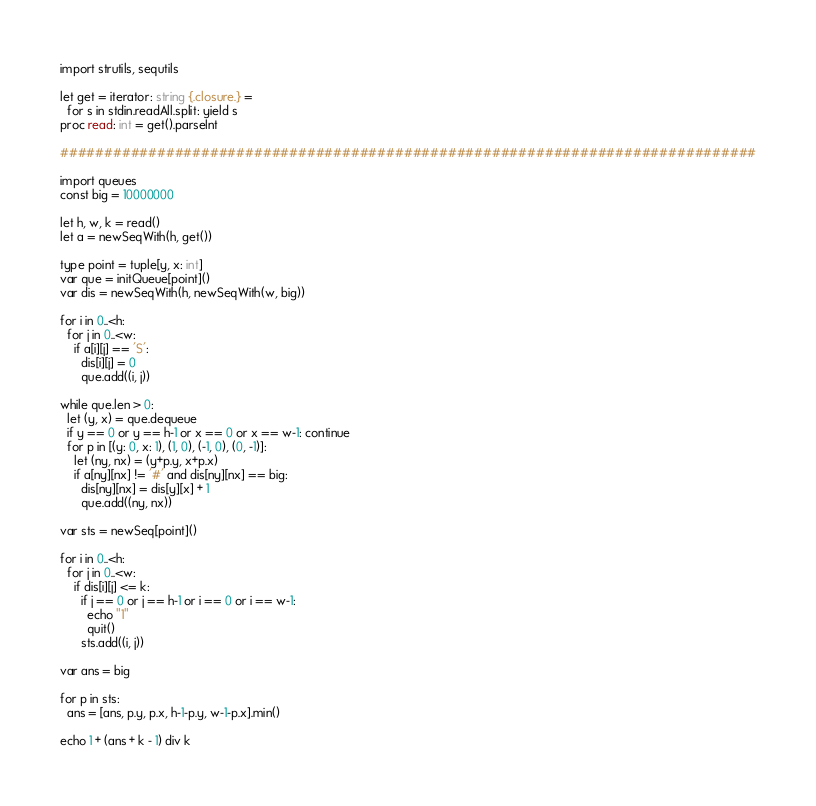<code> <loc_0><loc_0><loc_500><loc_500><_Nim_>import strutils, sequtils

let get = iterator: string {.closure.} =
  for s in stdin.readAll.split: yield s
proc read: int = get().parseInt

###############################################################################

import queues
const big = 10000000

let h, w, k = read()
let a = newSeqWith(h, get())

type point = tuple[y, x: int]
var que = initQueue[point]()
var dis = newSeqWith(h, newSeqWith(w, big))

for i in 0..<h:
  for j in 0..<w:
    if a[i][j] == 'S':
      dis[i][j] = 0
      que.add((i, j))
  
while que.len > 0:
  let (y, x) = que.dequeue
  if y == 0 or y == h-1 or x == 0 or x == w-1: continue
  for p in [(y: 0, x: 1), (1, 0), (-1, 0), (0, -1)]:
    let (ny, nx) = (y+p.y, x+p.x)
    if a[ny][nx] != '#' and dis[ny][nx] == big:
      dis[ny][nx] = dis[y][x] + 1
      que.add((ny, nx))

var sts = newSeq[point]()
      
for i in 0..<h:
  for j in 0..<w:
    if dis[i][j] <= k:
      if j == 0 or j == h-1 or i == 0 or i == w-1:
        echo "1"
        quit()
      sts.add((i, j))

var ans = big

for p in sts:
  ans = [ans, p.y, p.x, h-1-p.y, w-1-p.x].min()

echo 1 + (ans + k - 1) div k</code> 